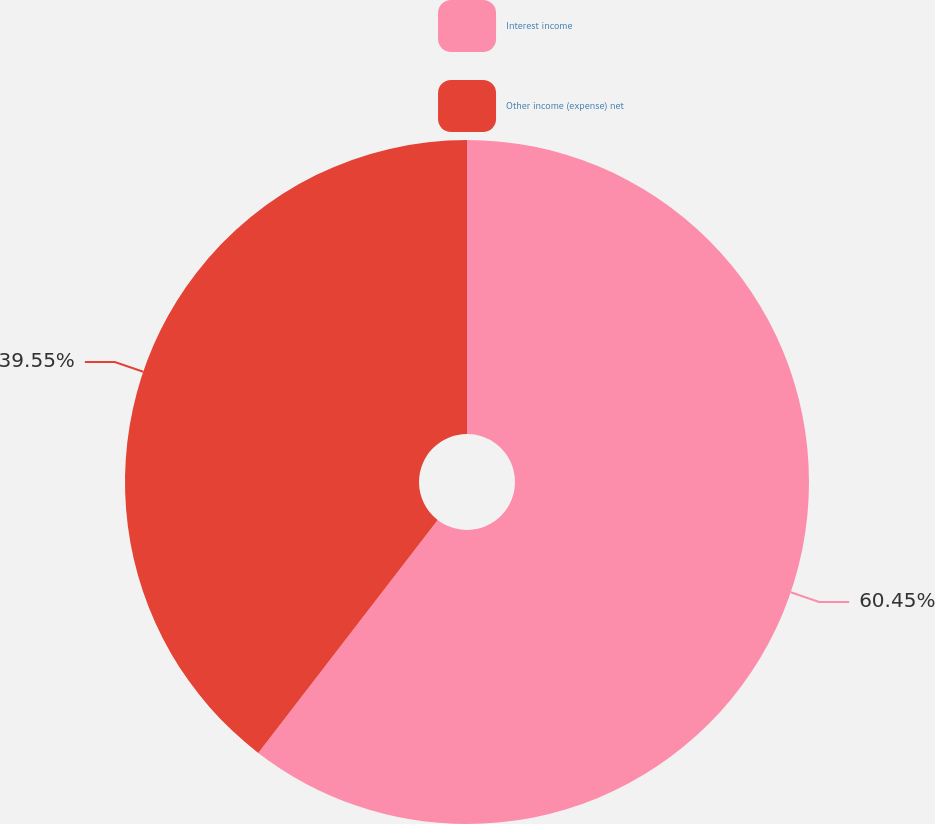<chart> <loc_0><loc_0><loc_500><loc_500><pie_chart><fcel>Interest income<fcel>Other income (expense) net<nl><fcel>60.45%<fcel>39.55%<nl></chart> 